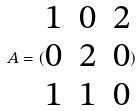<formula> <loc_0><loc_0><loc_500><loc_500>A = ( \begin{matrix} 1 & 0 & 2 \\ 0 & 2 & 0 \\ 1 & 1 & 0 \end{matrix} )</formula> 